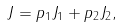<formula> <loc_0><loc_0><loc_500><loc_500>J = p _ { 1 } J _ { 1 } + p _ { 2 } J _ { 2 } ,</formula> 